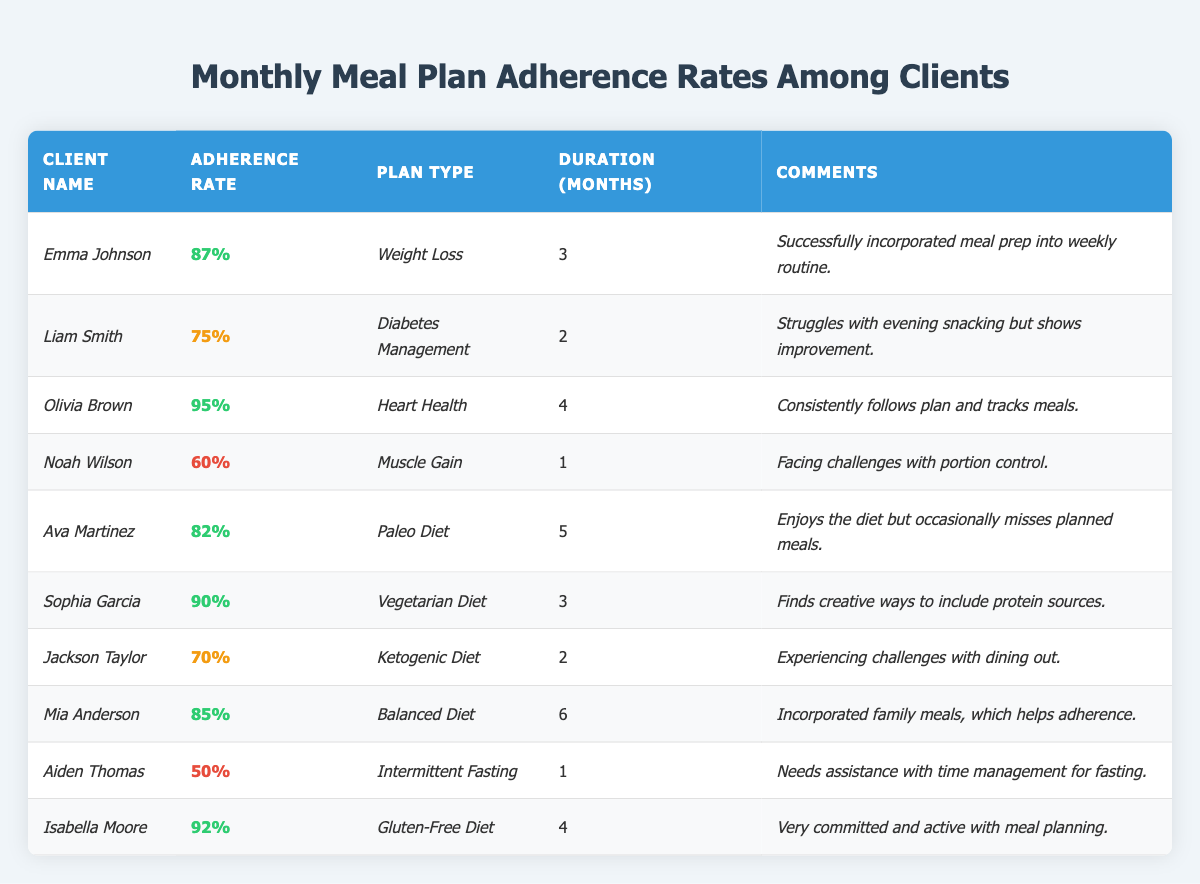What is the highest adherence rate among the clients? Referring to the table, I look at the "Adherence Rate" column and compare the values. The highest value is 95%.
Answer: 95% How many clients have an adherence rate below 70%? I check the "Adherence Rate" column for values less than 70%. The clients with rates of 60% and 50% are below this threshold, totaling 2 clients.
Answer: 2 What is the average adherence rate of all clients listed? To find the average, I sum all the adherence rates: 87 + 75 + 95 + 60 + 82 + 90 + 70 + 85 + 50 + 92 =  84.5, and divide by the number of clients (10).
Answer: 84.5 Is there any client who follows a "Balanced Diet"? Looking for the "Plan Type" column, I see that Mia Anderson follows a Balanced Diet. Thus, the answer is yes.
Answer: Yes Which client has been on their meal plan for the longest duration? Checking the "Duration (Months)" column, I see that Mia Anderson has been on her plan for 6 months, which is the highest duration.
Answer: Mia Anderson What is the difference between the highest and lowest adherence rates? The highest adherence rate is 95% (Olivia Brown) and the lowest is 50% (Aiden Thomas). The difference is 95 - 50 = 45.
Answer: 45 How many clients have a comment that mentions challenges with meal adherence? I scan the "Comments" column for indications of challenges. Clients Liam Smith, Noah Wilson, Jackson Taylor, and Aiden Thomas mention challenges, so there are 4 clients.
Answer: 4 Is there a client who has shown improvement in their adherence rate? Referring to the comments, I see that Liam Smith's comment states he shows improvement, so yes, there is a client with noted improvement.
Answer: Yes What percentage of clients are on a diet with adherence over 80%? From the table, I see that 6 clients (Emma, Olivia, Sophia, Ava, Mia, Isabella) have an adherence rate over 80%. To find the percentage: (6/10) * 100 = 60%.
Answer: 60% Which dietary plan has the lowest adherence rate, and what is that rate? Reviewing the adherence rates, I determine that the "Intermittent Fasting" plan (client Aiden Thomas) has the lowest rate at 50%.
Answer: Intermittent Fasting, 50% 